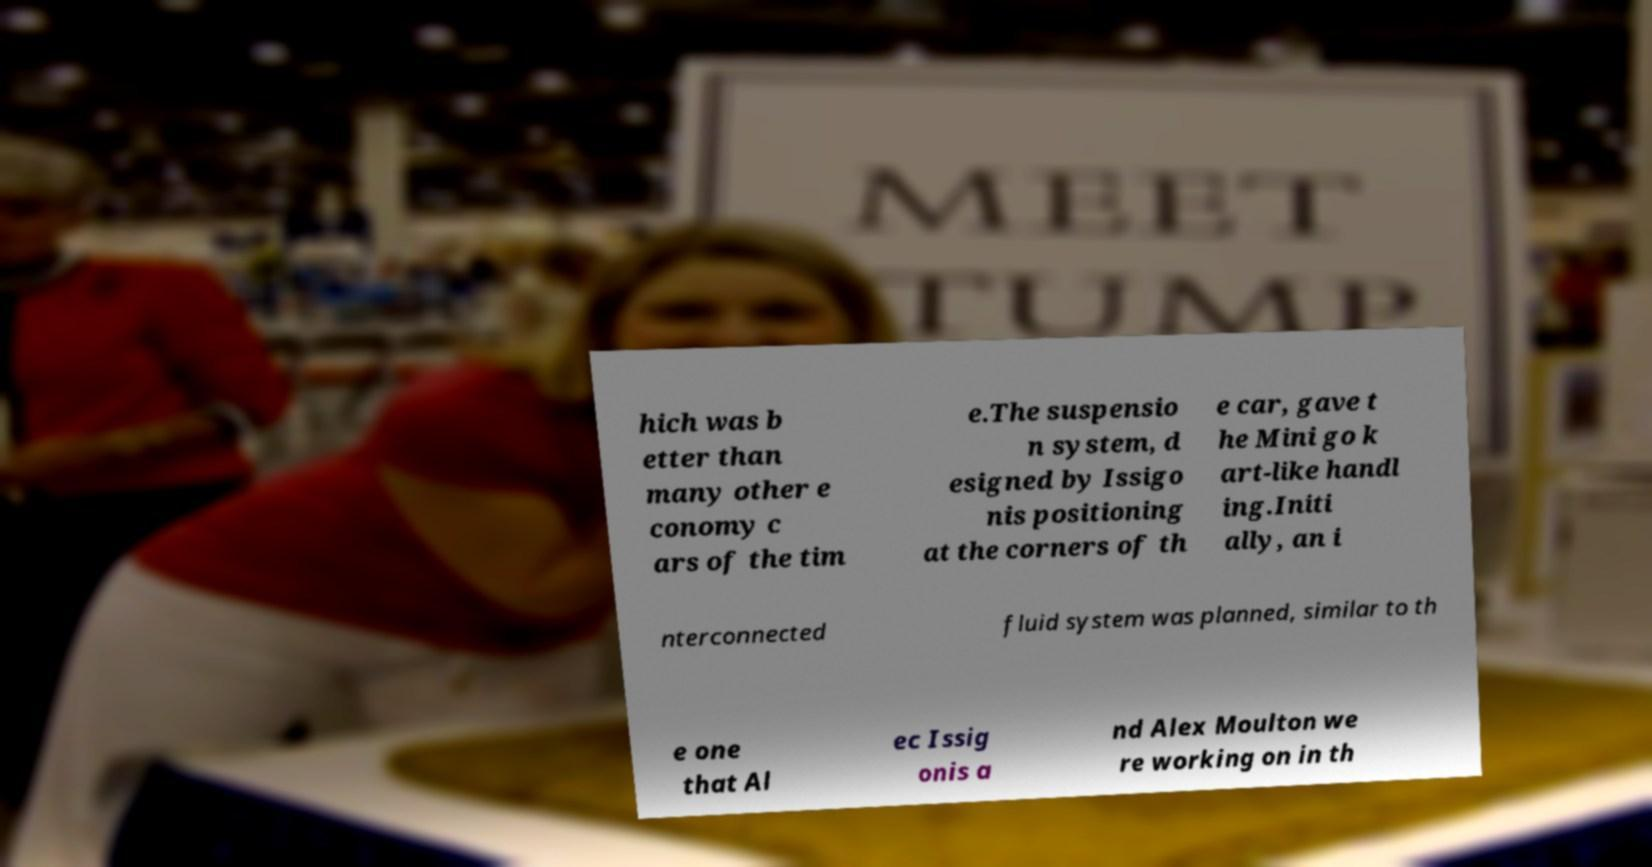Please read and relay the text visible in this image. What does it say? hich was b etter than many other e conomy c ars of the tim e.The suspensio n system, d esigned by Issigo nis positioning at the corners of th e car, gave t he Mini go k art-like handl ing.Initi ally, an i nterconnected fluid system was planned, similar to th e one that Al ec Issig onis a nd Alex Moulton we re working on in th 